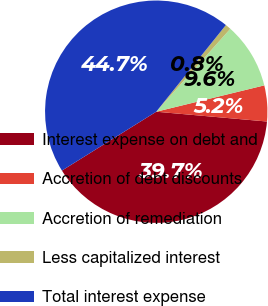Convert chart. <chart><loc_0><loc_0><loc_500><loc_500><pie_chart><fcel>Interest expense on debt and<fcel>Accretion of debt discounts<fcel>Accretion of remediation<fcel>Less capitalized interest<fcel>Total interest expense<nl><fcel>39.71%<fcel>5.21%<fcel>9.59%<fcel>0.83%<fcel>44.65%<nl></chart> 